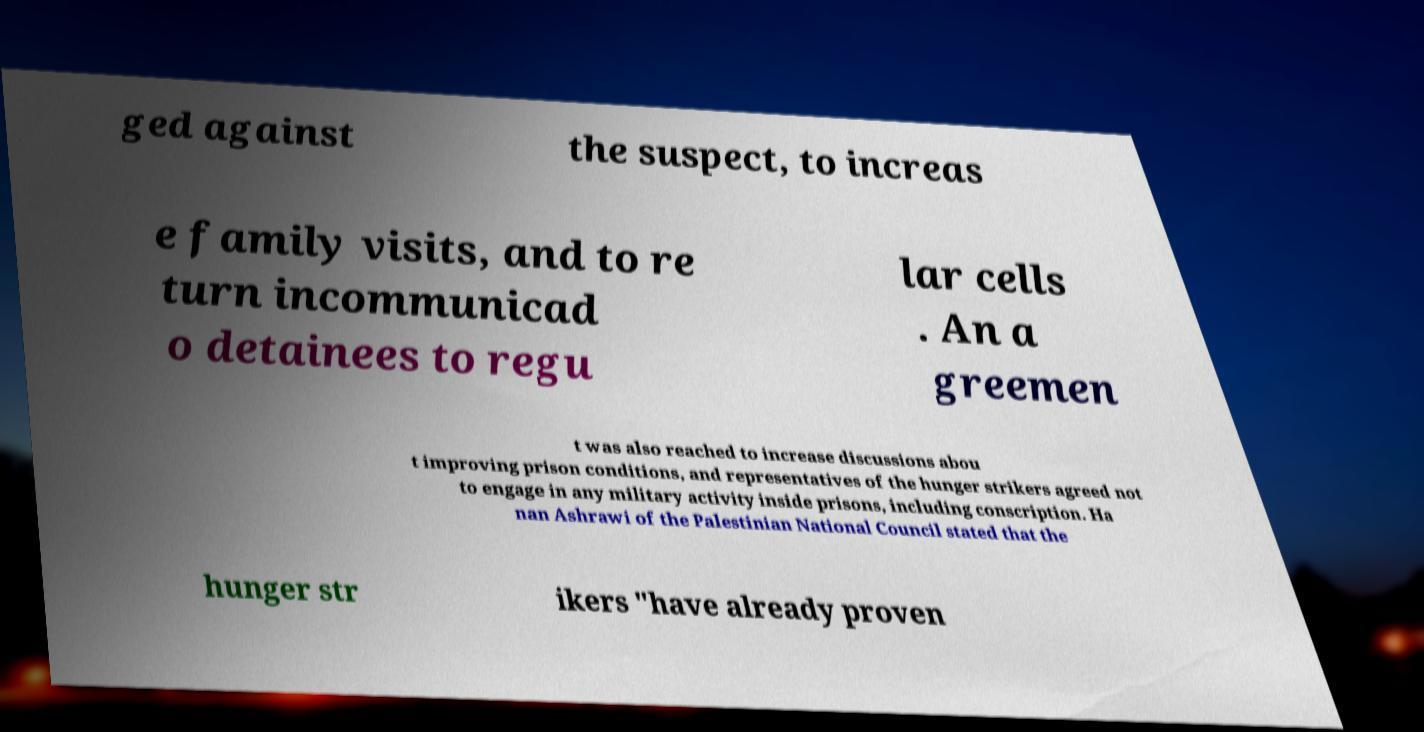What messages or text are displayed in this image? I need them in a readable, typed format. ged against the suspect, to increas e family visits, and to re turn incommunicad o detainees to regu lar cells . An a greemen t was also reached to increase discussions abou t improving prison conditions, and representatives of the hunger strikers agreed not to engage in any military activity inside prisons, including conscription. Ha nan Ashrawi of the Palestinian National Council stated that the hunger str ikers "have already proven 